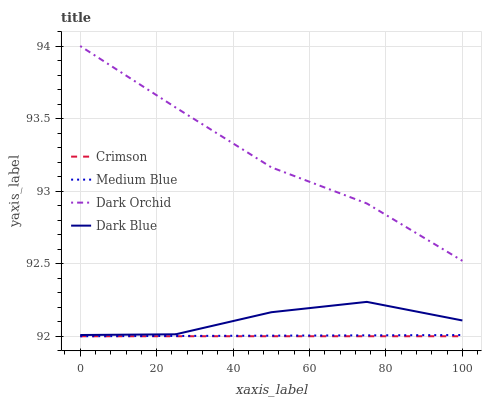Does Crimson have the minimum area under the curve?
Answer yes or no. Yes. Does Dark Orchid have the maximum area under the curve?
Answer yes or no. Yes. Does Dark Blue have the minimum area under the curve?
Answer yes or no. No. Does Dark Blue have the maximum area under the curve?
Answer yes or no. No. Is Crimson the smoothest?
Answer yes or no. Yes. Is Dark Blue the roughest?
Answer yes or no. Yes. Is Medium Blue the smoothest?
Answer yes or no. No. Is Medium Blue the roughest?
Answer yes or no. No. Does Dark Blue have the lowest value?
Answer yes or no. No. Does Dark Orchid have the highest value?
Answer yes or no. Yes. Does Dark Blue have the highest value?
Answer yes or no. No. Is Crimson less than Dark Blue?
Answer yes or no. Yes. Is Dark Orchid greater than Dark Blue?
Answer yes or no. Yes. Does Medium Blue intersect Crimson?
Answer yes or no. Yes. Is Medium Blue less than Crimson?
Answer yes or no. No. Is Medium Blue greater than Crimson?
Answer yes or no. No. Does Crimson intersect Dark Blue?
Answer yes or no. No. 